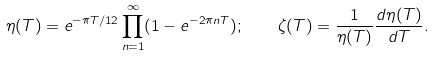<formula> <loc_0><loc_0><loc_500><loc_500>\eta ( T ) = e ^ { - \pi T / 1 2 } \prod _ { n = 1 } ^ { \infty } ( 1 - e ^ { - 2 \pi n T } ) ; \quad \zeta ( T ) = \frac { 1 } { \eta ( T ) } \frac { d \eta ( T ) } { d T } .</formula> 